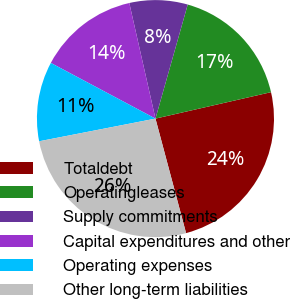Convert chart. <chart><loc_0><loc_0><loc_500><loc_500><pie_chart><fcel>Totaldebt<fcel>Operatingleases<fcel>Supply commitments<fcel>Capital expenditures and other<fcel>Operating expenses<fcel>Other long-term liabilities<nl><fcel>24.42%<fcel>17.03%<fcel>7.93%<fcel>13.67%<fcel>10.85%<fcel>26.09%<nl></chart> 